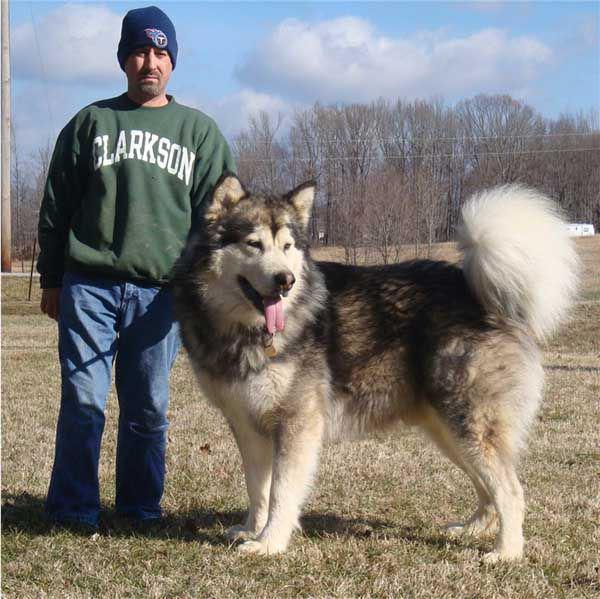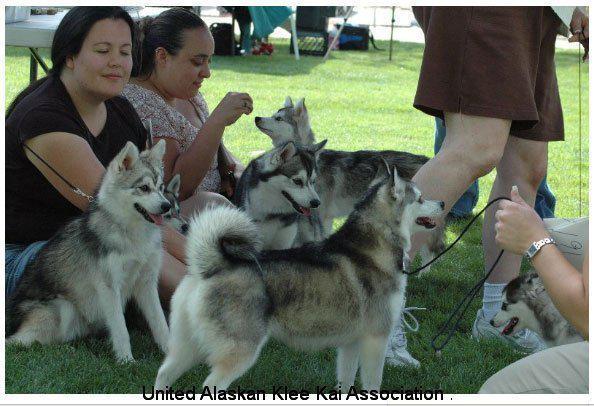The first image is the image on the left, the second image is the image on the right. Examine the images to the left and right. Is the description "The right image contains at least two dogs." accurate? Answer yes or no. Yes. The first image is the image on the left, the second image is the image on the right. For the images shown, is this caption "There is a person in a green top standing near the dog." true? Answer yes or no. Yes. 